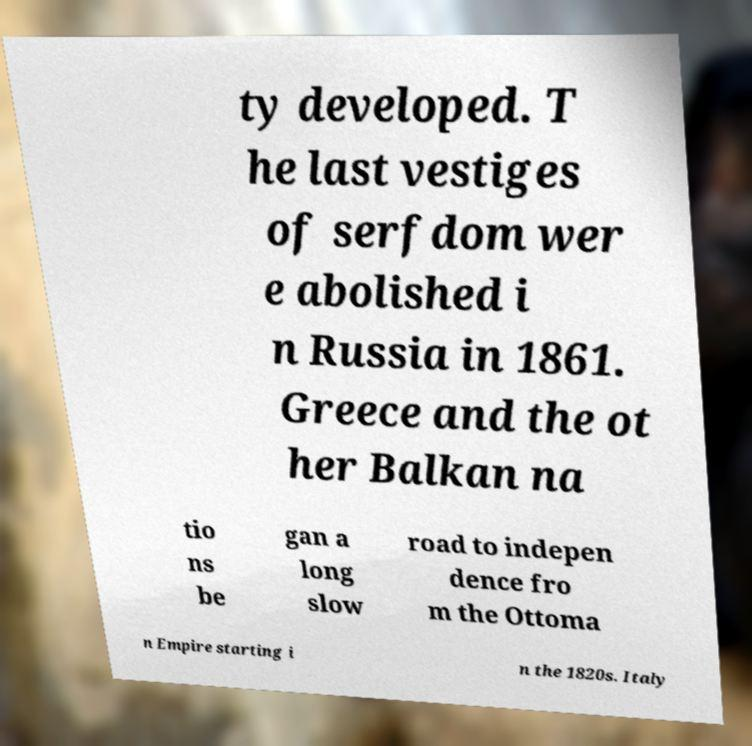Please read and relay the text visible in this image. What does it say? ty developed. T he last vestiges of serfdom wer e abolished i n Russia in 1861. Greece and the ot her Balkan na tio ns be gan a long slow road to indepen dence fro m the Ottoma n Empire starting i n the 1820s. Italy 